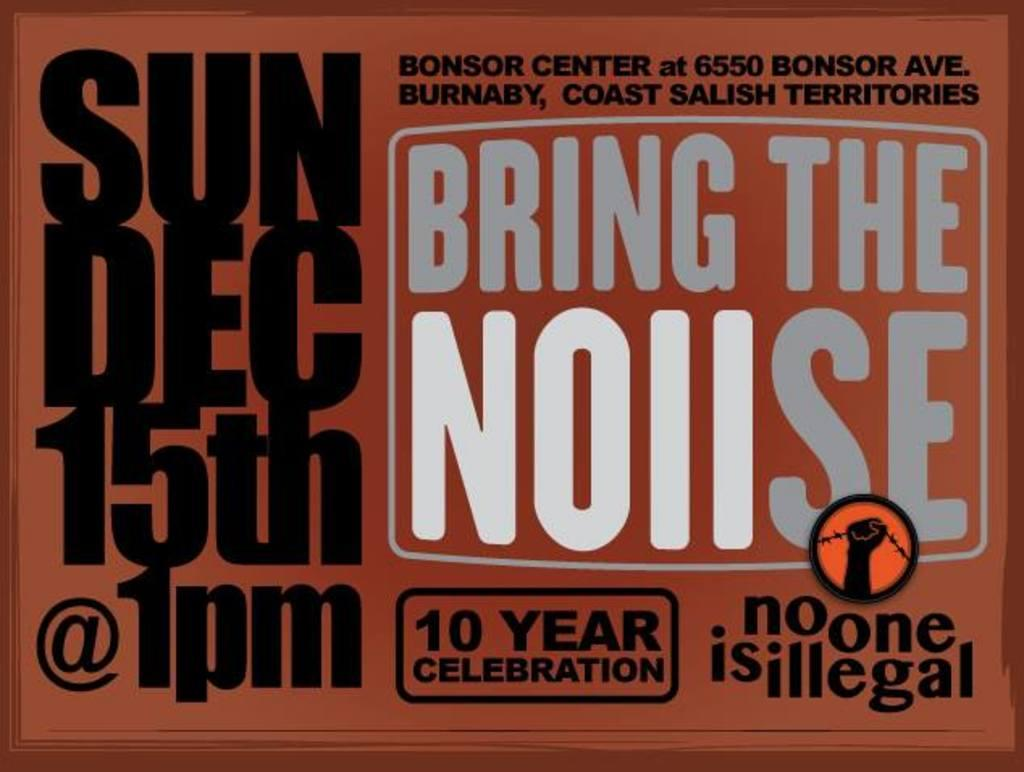<image>
Write a terse but informative summary of the picture. Orange sign that says Bring The Noiise which takes place on Dec 15th. 